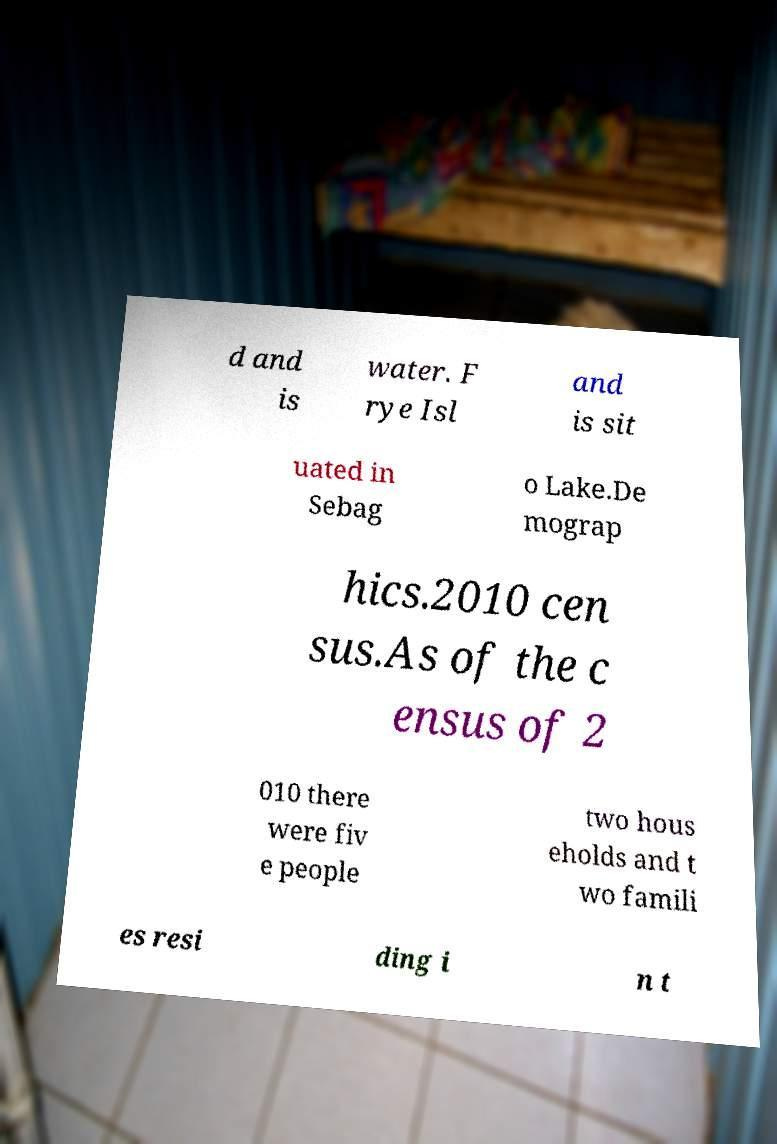Can you accurately transcribe the text from the provided image for me? d and is water. F rye Isl and is sit uated in Sebag o Lake.De mograp hics.2010 cen sus.As of the c ensus of 2 010 there were fiv e people two hous eholds and t wo famili es resi ding i n t 